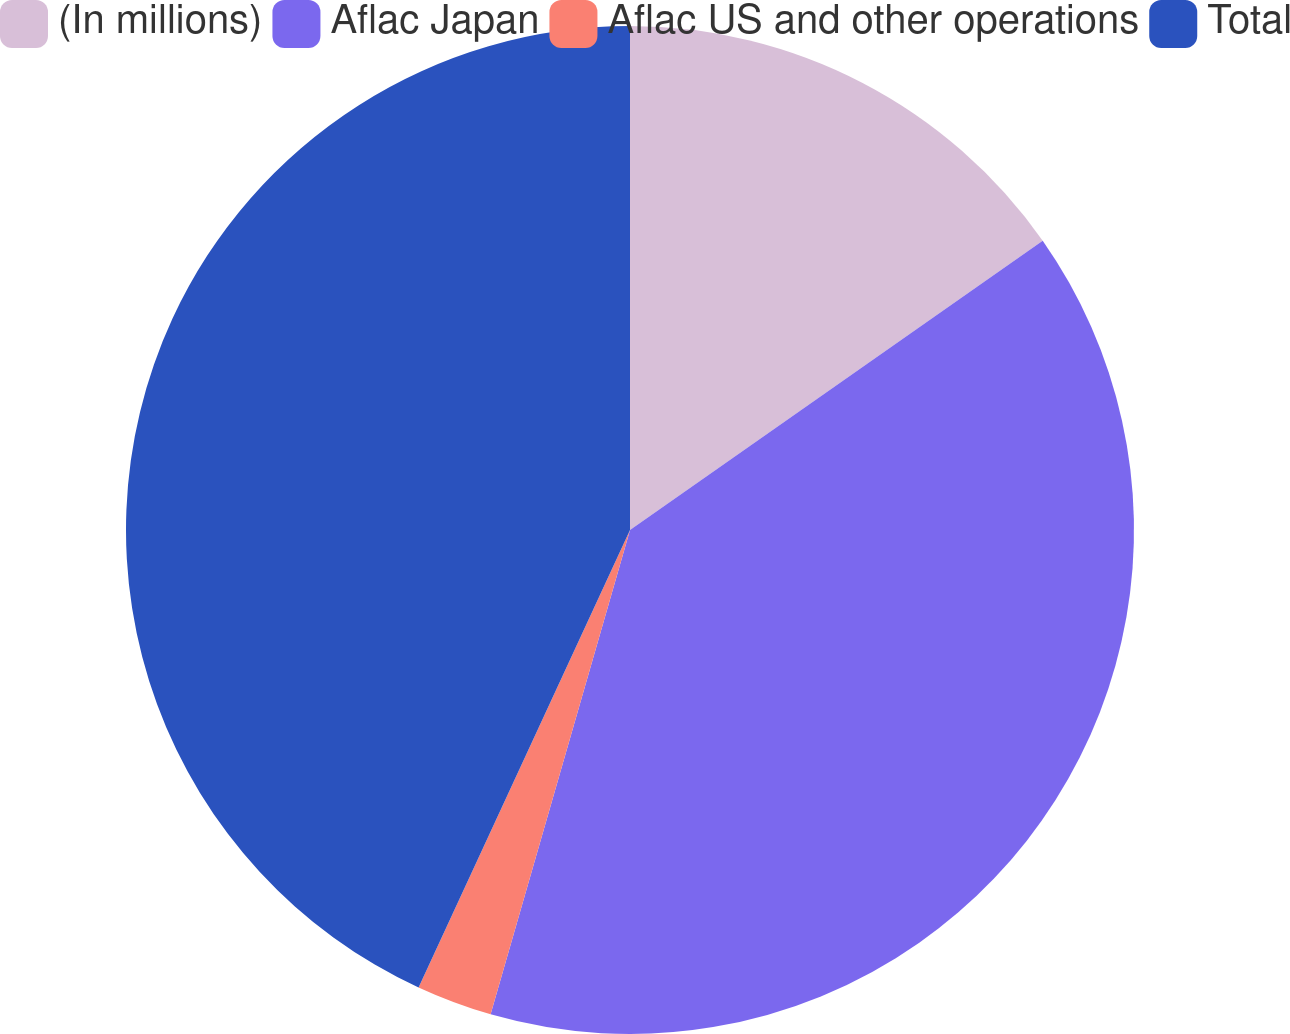Convert chart to OTSL. <chart><loc_0><loc_0><loc_500><loc_500><pie_chart><fcel>(In millions)<fcel>Aflac Japan<fcel>Aflac US and other operations<fcel>Total<nl><fcel>15.27%<fcel>39.19%<fcel>2.43%<fcel>43.11%<nl></chart> 